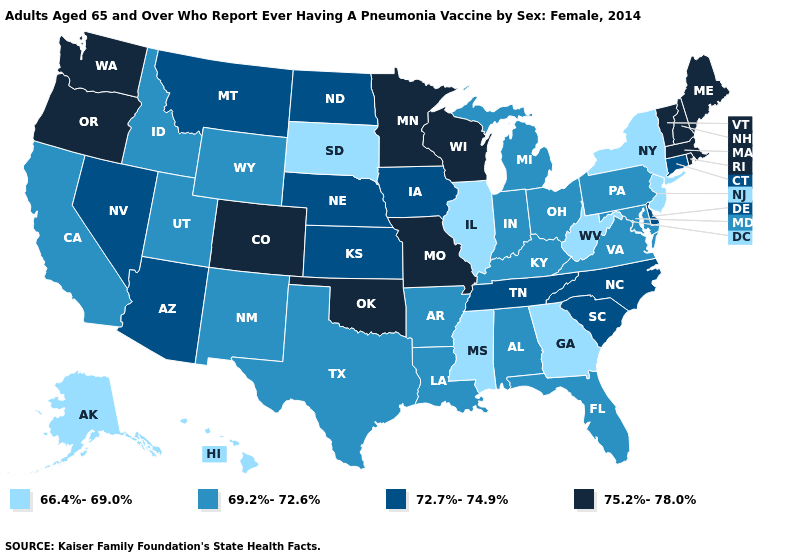Name the states that have a value in the range 75.2%-78.0%?
Short answer required. Colorado, Maine, Massachusetts, Minnesota, Missouri, New Hampshire, Oklahoma, Oregon, Rhode Island, Vermont, Washington, Wisconsin. What is the value of Kentucky?
Short answer required. 69.2%-72.6%. Does Maine have a higher value than South Dakota?
Be succinct. Yes. Name the states that have a value in the range 75.2%-78.0%?
Short answer required. Colorado, Maine, Massachusetts, Minnesota, Missouri, New Hampshire, Oklahoma, Oregon, Rhode Island, Vermont, Washington, Wisconsin. Does New York have the lowest value in the Northeast?
Give a very brief answer. Yes. How many symbols are there in the legend?
Be succinct. 4. Does Massachusetts have a lower value than Illinois?
Quick response, please. No. Name the states that have a value in the range 69.2%-72.6%?
Answer briefly. Alabama, Arkansas, California, Florida, Idaho, Indiana, Kentucky, Louisiana, Maryland, Michigan, New Mexico, Ohio, Pennsylvania, Texas, Utah, Virginia, Wyoming. Among the states that border North Dakota , which have the lowest value?
Answer briefly. South Dakota. Is the legend a continuous bar?
Give a very brief answer. No. What is the lowest value in the USA?
Be succinct. 66.4%-69.0%. Name the states that have a value in the range 72.7%-74.9%?
Give a very brief answer. Arizona, Connecticut, Delaware, Iowa, Kansas, Montana, Nebraska, Nevada, North Carolina, North Dakota, South Carolina, Tennessee. What is the value of New Jersey?
Write a very short answer. 66.4%-69.0%. Which states hav the highest value in the West?
Answer briefly. Colorado, Oregon, Washington. Name the states that have a value in the range 69.2%-72.6%?
Keep it brief. Alabama, Arkansas, California, Florida, Idaho, Indiana, Kentucky, Louisiana, Maryland, Michigan, New Mexico, Ohio, Pennsylvania, Texas, Utah, Virginia, Wyoming. 